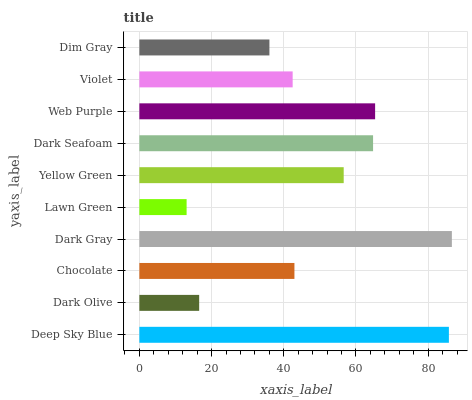Is Lawn Green the minimum?
Answer yes or no. Yes. Is Dark Gray the maximum?
Answer yes or no. Yes. Is Dark Olive the minimum?
Answer yes or no. No. Is Dark Olive the maximum?
Answer yes or no. No. Is Deep Sky Blue greater than Dark Olive?
Answer yes or no. Yes. Is Dark Olive less than Deep Sky Blue?
Answer yes or no. Yes. Is Dark Olive greater than Deep Sky Blue?
Answer yes or no. No. Is Deep Sky Blue less than Dark Olive?
Answer yes or no. No. Is Yellow Green the high median?
Answer yes or no. Yes. Is Chocolate the low median?
Answer yes or no. Yes. Is Lawn Green the high median?
Answer yes or no. No. Is Dark Olive the low median?
Answer yes or no. No. 